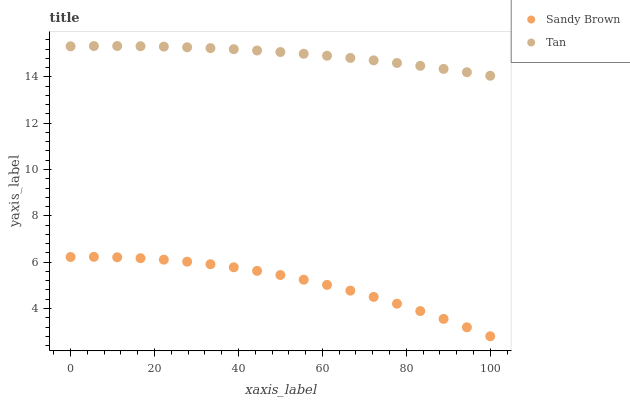Does Sandy Brown have the minimum area under the curve?
Answer yes or no. Yes. Does Tan have the maximum area under the curve?
Answer yes or no. Yes. Does Sandy Brown have the maximum area under the curve?
Answer yes or no. No. Is Tan the smoothest?
Answer yes or no. Yes. Is Sandy Brown the roughest?
Answer yes or no. Yes. Is Sandy Brown the smoothest?
Answer yes or no. No. Does Sandy Brown have the lowest value?
Answer yes or no. Yes. Does Tan have the highest value?
Answer yes or no. Yes. Does Sandy Brown have the highest value?
Answer yes or no. No. Is Sandy Brown less than Tan?
Answer yes or no. Yes. Is Tan greater than Sandy Brown?
Answer yes or no. Yes. Does Sandy Brown intersect Tan?
Answer yes or no. No. 